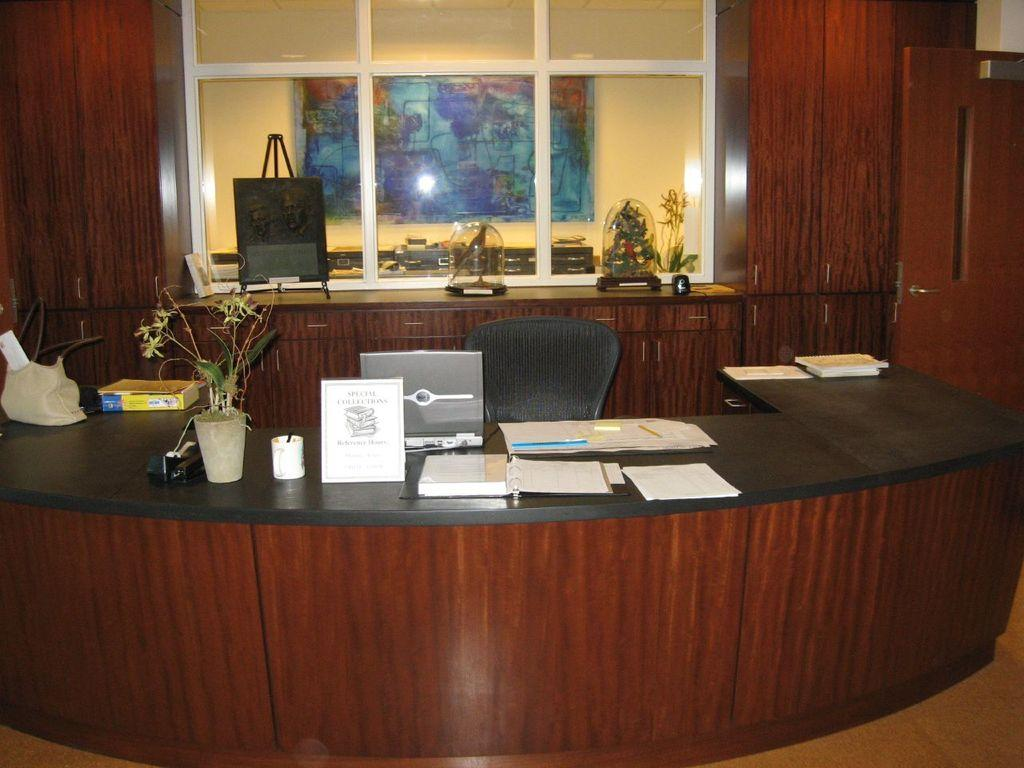What type of furniture is present in the image? There is a chair in the image. What object is used for carrying items and is visible in the image? There is a bag in the image. What is the primary surface for placing objects in the image? There is a table in the image. What items can be seen on the table? There are papers, a laptop, a plant, another bag, and a book on the table. What can be seen through the window in the image? There is a yellow color wall and a banner outside the window. What type of cabbage is growing on the table in the image? There is no cabbage present on the table in the image. How many trees can be seen through the window in the image? There are no trees visible through the window in the image. 